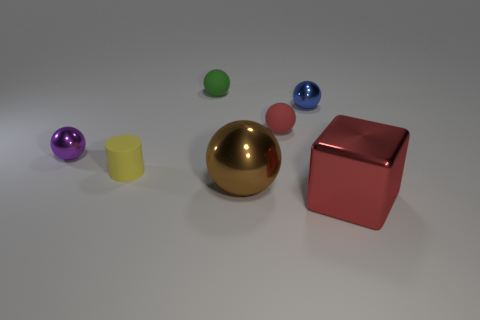There is a matte thing that is to the right of the green matte sphere; what color is it?
Give a very brief answer. Red. What color is the tiny metallic object that is in front of the small metallic object that is to the right of the tiny purple ball?
Your response must be concise. Purple. What is the color of the rubber ball that is the same size as the green rubber thing?
Offer a very short reply. Red. What number of metal spheres are on the left side of the blue shiny ball and behind the tiny yellow matte object?
Give a very brief answer. 1. What shape is the rubber object that is the same color as the block?
Your answer should be very brief. Sphere. There is a object that is in front of the yellow object and to the left of the red block; what is its material?
Ensure brevity in your answer.  Metal. Is the number of blue metallic things behind the green rubber sphere less than the number of tiny yellow matte objects that are behind the tiny purple metallic ball?
Make the answer very short. No. What size is the red thing that is the same material as the small yellow object?
Your response must be concise. Small. Is there anything else that is the same color as the big shiny block?
Provide a succinct answer. Yes. Are the tiny blue sphere and the large thing to the left of the red sphere made of the same material?
Give a very brief answer. Yes. 